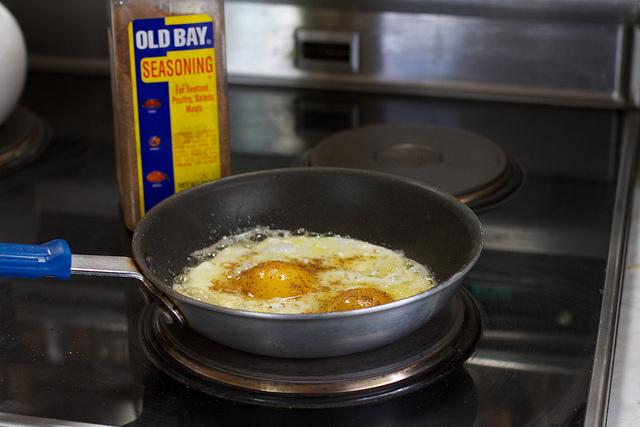What color is the pot's handle?
Concise answer only. Blue. What is in the pan?
Give a very brief answer. Eggs. What kind of seasoning was used?
Concise answer only. Old bay. 